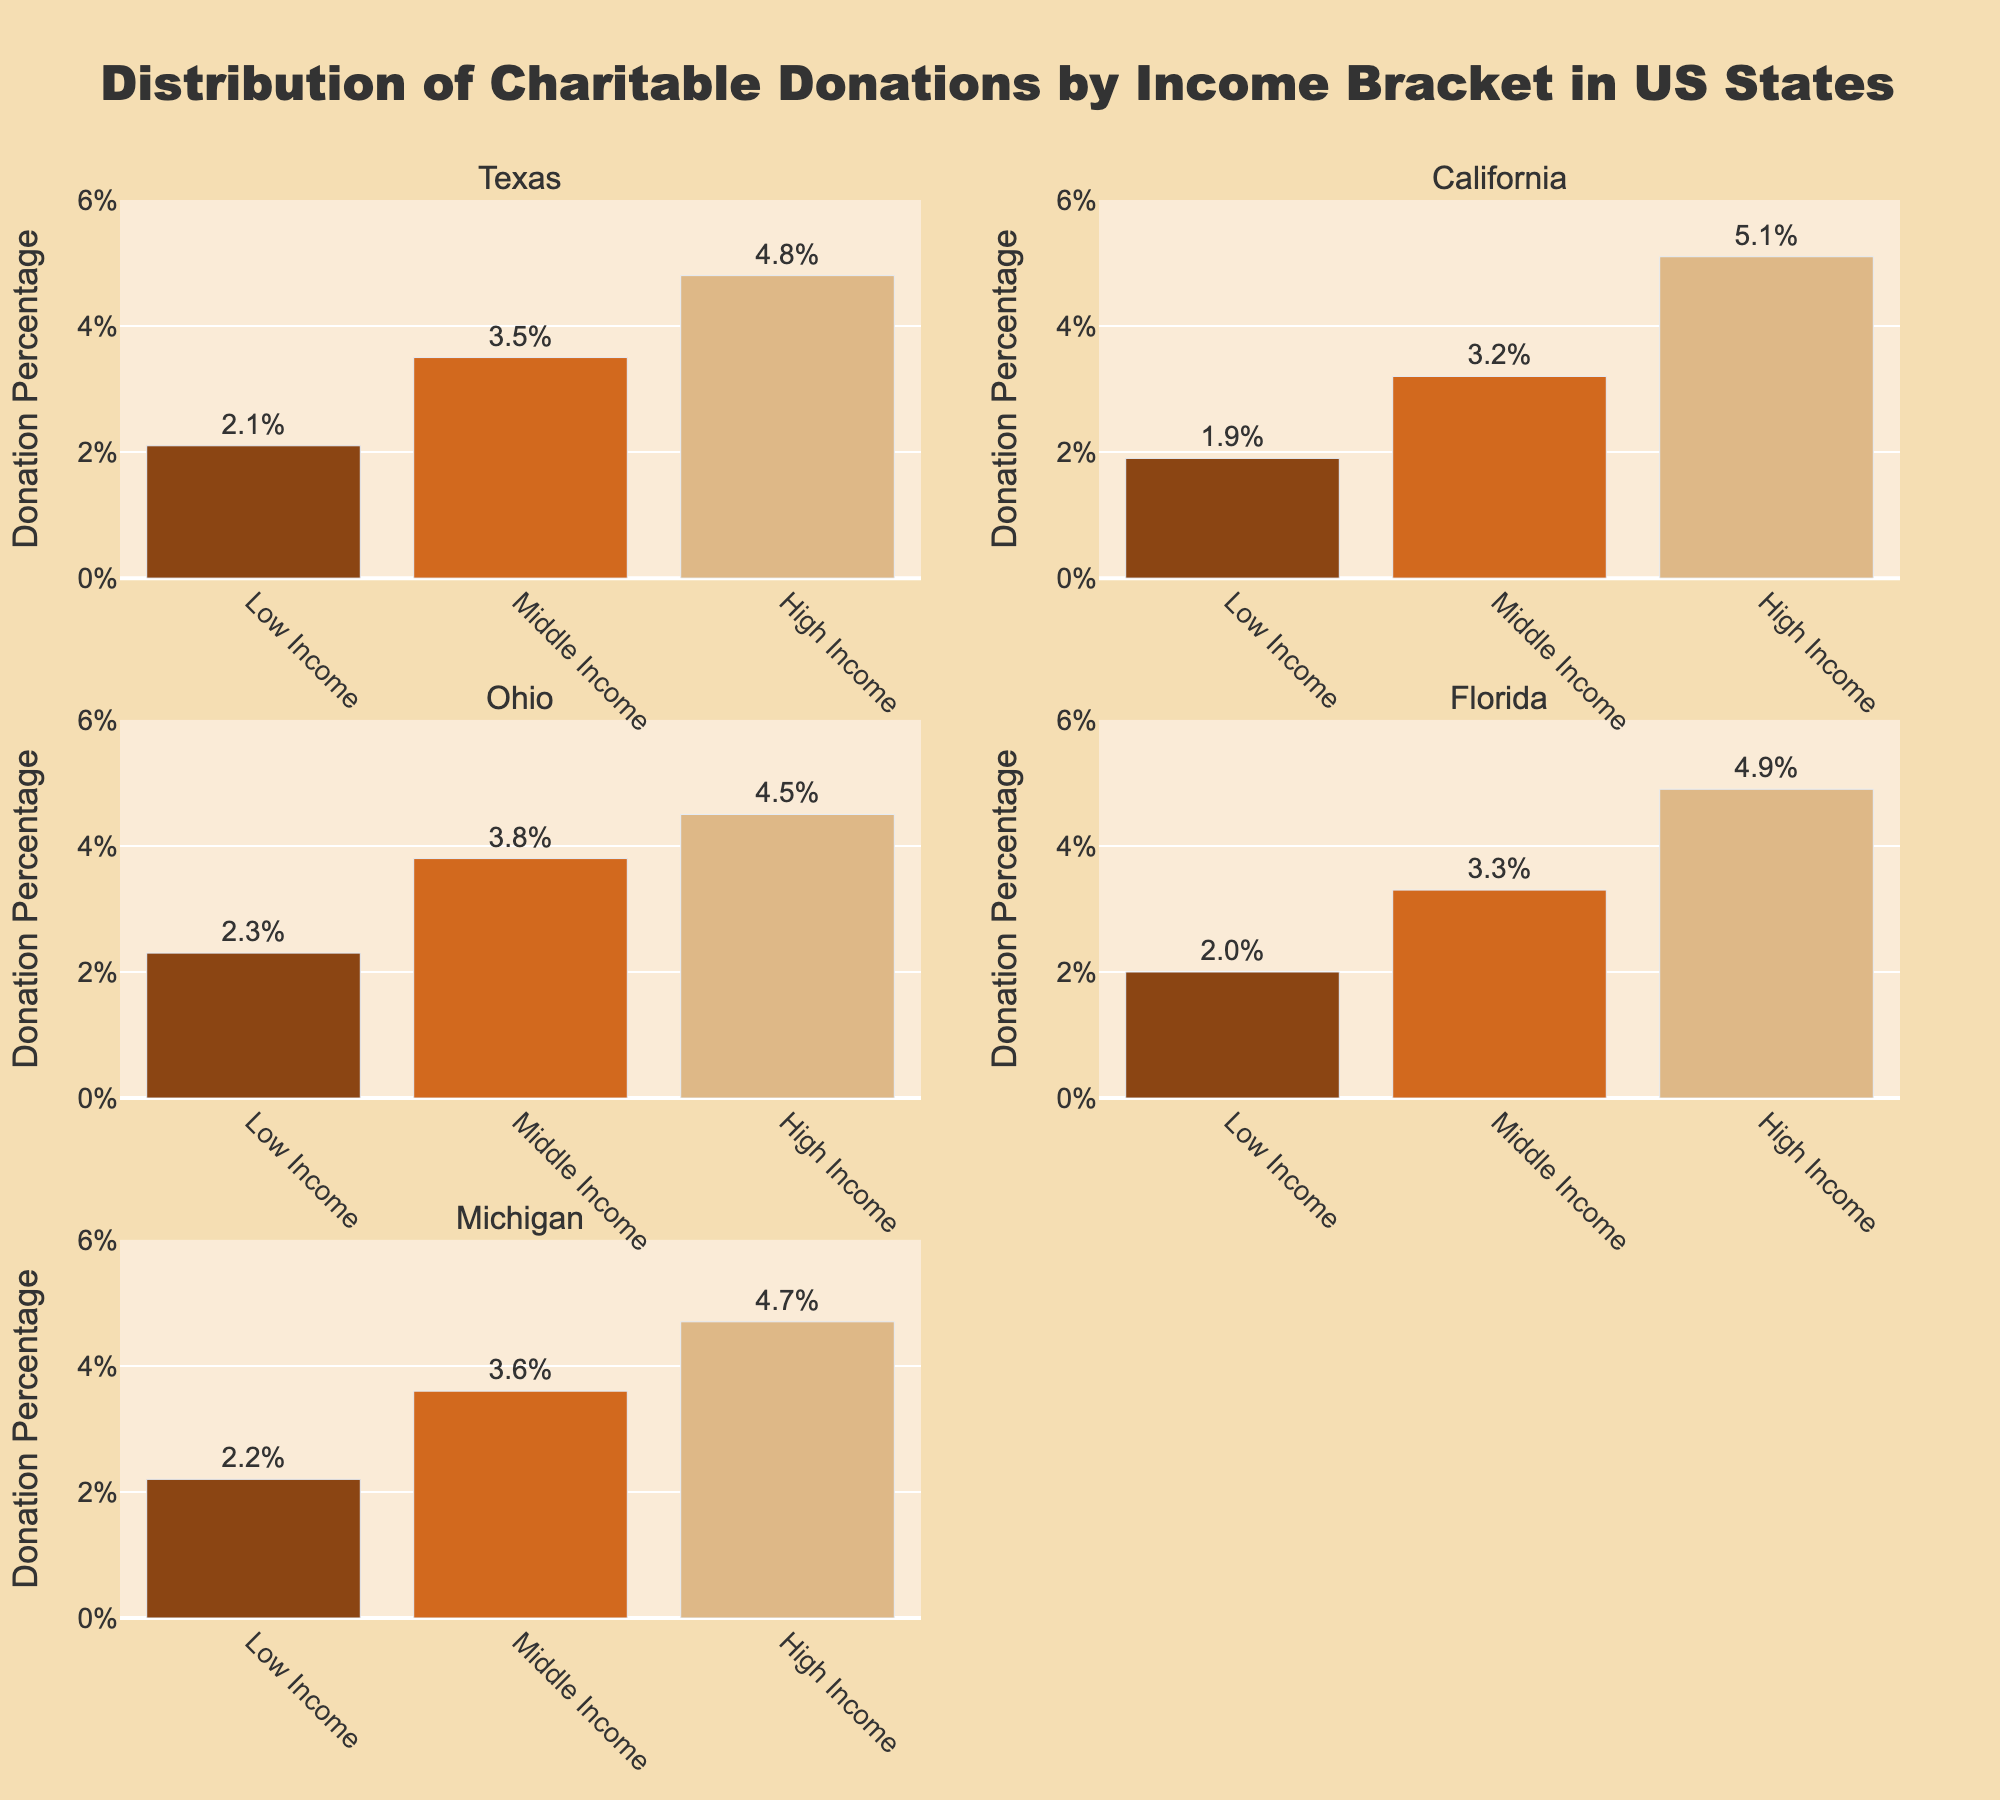Which state has the highest donation percentage for the high-income bracket? Look at the values for the high-income bracket in each state subplot. California has the highest at 5.1%.
Answer: California Which income bracket in Ohio has the lowest donation percentage? For Ohio, compare the donation percentages of all three income brackets. The low-income bracket has the lowest at 2.3%.
Answer: Low Income Which state shows the smallest difference in donation percentages between low and high-income brackets? Check the difference between low and high-income brackets for all states. Calculate: Texas (4.8-2.1=2.7), California (5.1-1.9=3.2), Ohio (4.5-2.3=2.2), Florida (4.9-2.0=2.9), Michigan (4.7-2.2=2.5). Ohio has the smallest difference.
Answer: Ohio What is the donation percentage for the middle-income bracket in Texas? Locate Texas and find the bar for the middle-income bracket. The value shown is 3.5%.
Answer: 3.5% Which state has the highest average donation percentage across all income brackets? Find the average donation percentage for each state: Texas (10.4/3=3.47), California (10.2/3=3.4), Ohio (10.6/3=3.53), Florida (10.2/3=3.4), Michigan (10.5/3=3.5). Ohio has the highest average.
Answer: Ohio In Michigan, how much greater is the high-income bracket's donation percentage compared to the middle-income bracket? Calculate the difference between high and middle-income brackets for Michigan (4.7-3.6=1.1).
Answer: 1.1% Which income bracket consistently has the lowest donation percentage across all states? Compare the values of each income bracket across all states. The low-income bracket consistently has the lowest donation percentages.
Answer: Low Income How do the donation percentages for low-income brackets in Ohio and Florida compare? Compare the donation percentages for the low-income brackets in both states: Ohio (2.3%) vs. Florida (2.0%). Ohio has a higher percentage.
Answer: Ohio What is the range of donation percentages for the high-income bracket across all states? Find the highest (California 5.1) and lowest (Ohio 4.5) donation percentages in the high-income bracket and calculate the range (5.1-4.5=0.6).
Answer: 0.6 In which state do middle-income earners donate the most relative to their income? Compare the middle-income brackets for all states: Texas (3.5%), California (3.2%), Ohio (3.8%), Florida (3.3%), Michigan (3.6%). Ohio's middle-income earners donate the most.
Answer: Ohio 